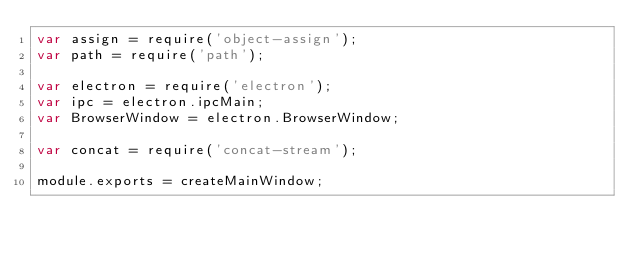<code> <loc_0><loc_0><loc_500><loc_500><_JavaScript_>var assign = require('object-assign');
var path = require('path');

var electron = require('electron');
var ipc = electron.ipcMain;
var BrowserWindow = electron.BrowserWindow;

var concat = require('concat-stream');

module.exports = createMainWindow;</code> 